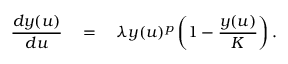<formula> <loc_0><loc_0><loc_500><loc_500>\frac { d y ( u ) } { d u } \quad = \quad \lambda y ( u ) ^ { p } \left ( 1 - \frac { y ( u ) } { K } \right ) .</formula> 